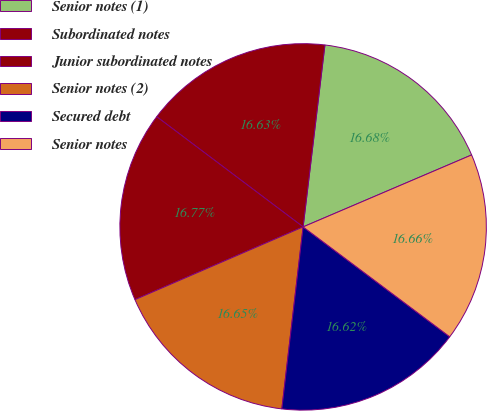Convert chart. <chart><loc_0><loc_0><loc_500><loc_500><pie_chart><fcel>Senior notes (1)<fcel>Subordinated notes<fcel>Junior subordinated notes<fcel>Senior notes (2)<fcel>Secured debt<fcel>Senior notes<nl><fcel>16.68%<fcel>16.63%<fcel>16.77%<fcel>16.65%<fcel>16.62%<fcel>16.66%<nl></chart> 